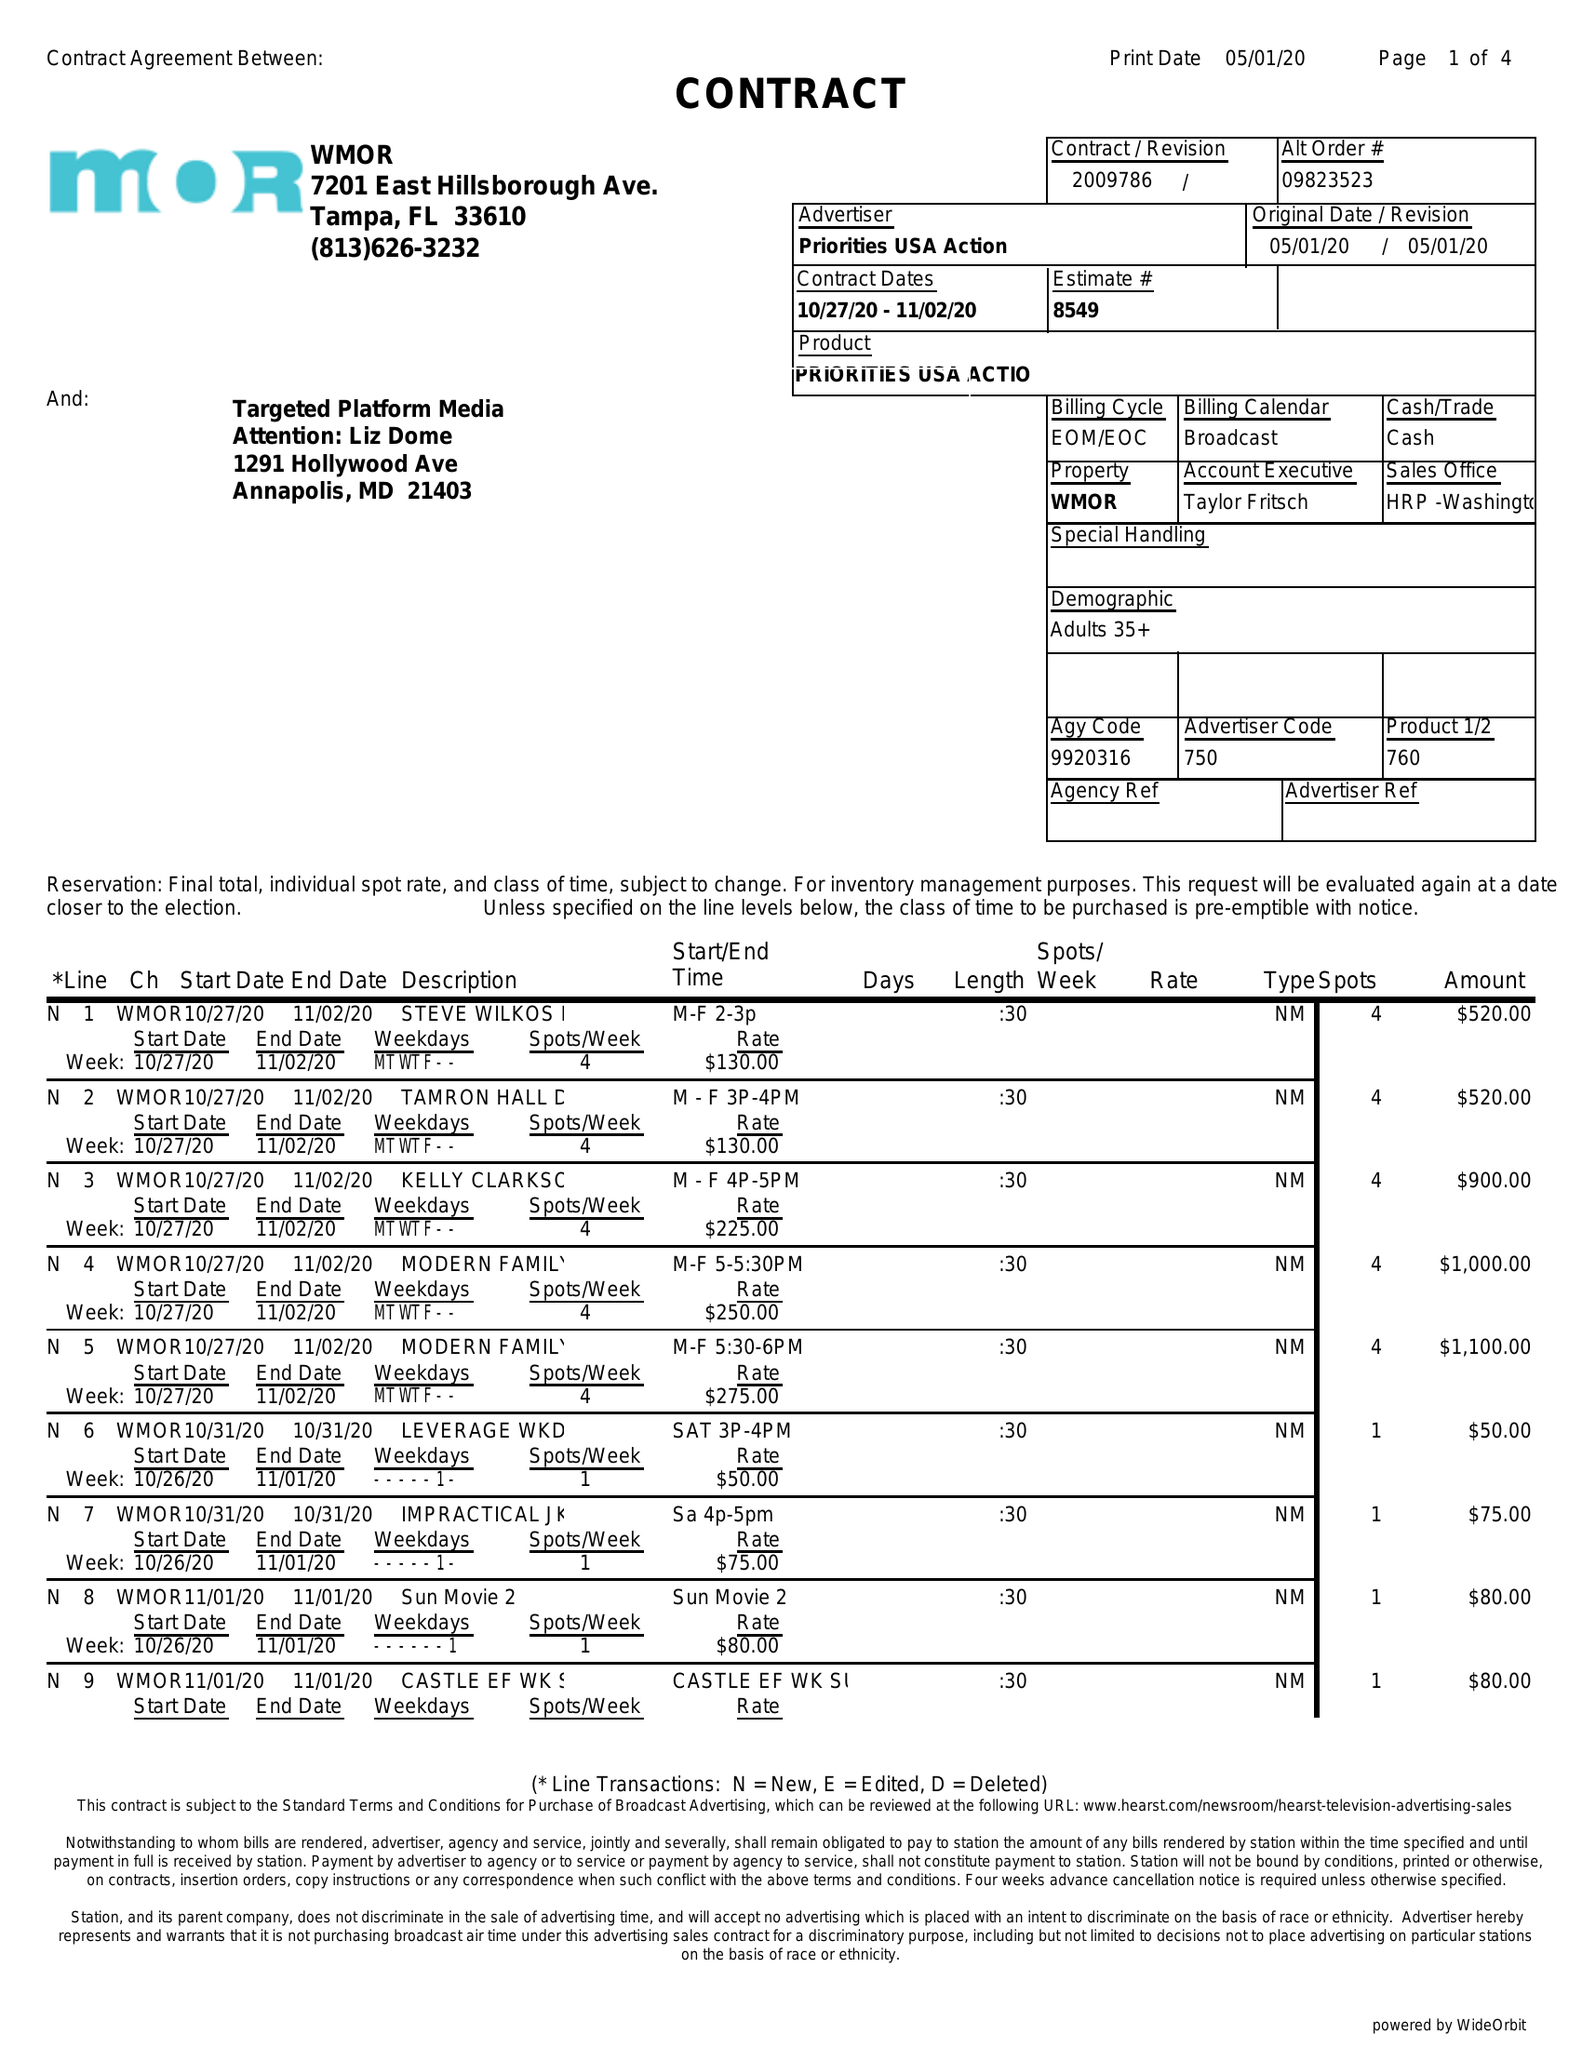What is the value for the gross_amount?
Answer the question using a single word or phrase. 16350.00 